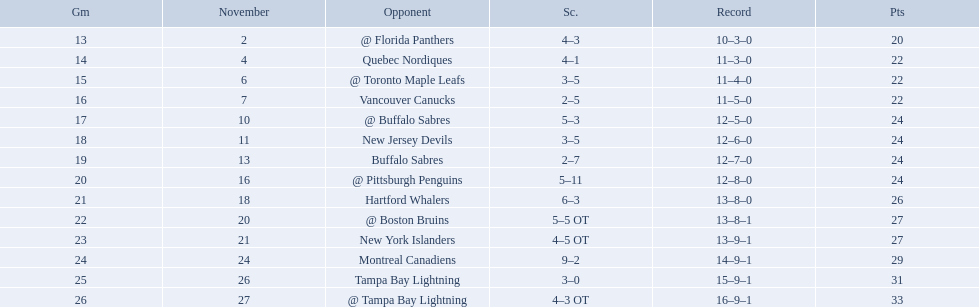Who did the philadelphia flyers play in game 17? @ Buffalo Sabres. What was the score of the november 10th game against the buffalo sabres? 5–3. Which team in the atlantic division had less points than the philadelphia flyers? Tampa Bay Lightning. Who are all of the teams? @ Florida Panthers, Quebec Nordiques, @ Toronto Maple Leafs, Vancouver Canucks, @ Buffalo Sabres, New Jersey Devils, Buffalo Sabres, @ Pittsburgh Penguins, Hartford Whalers, @ Boston Bruins, New York Islanders, Montreal Canadiens, Tampa Bay Lightning. What games finished in overtime? 22, 23, 26. In game number 23, who did they face? New York Islanders. 